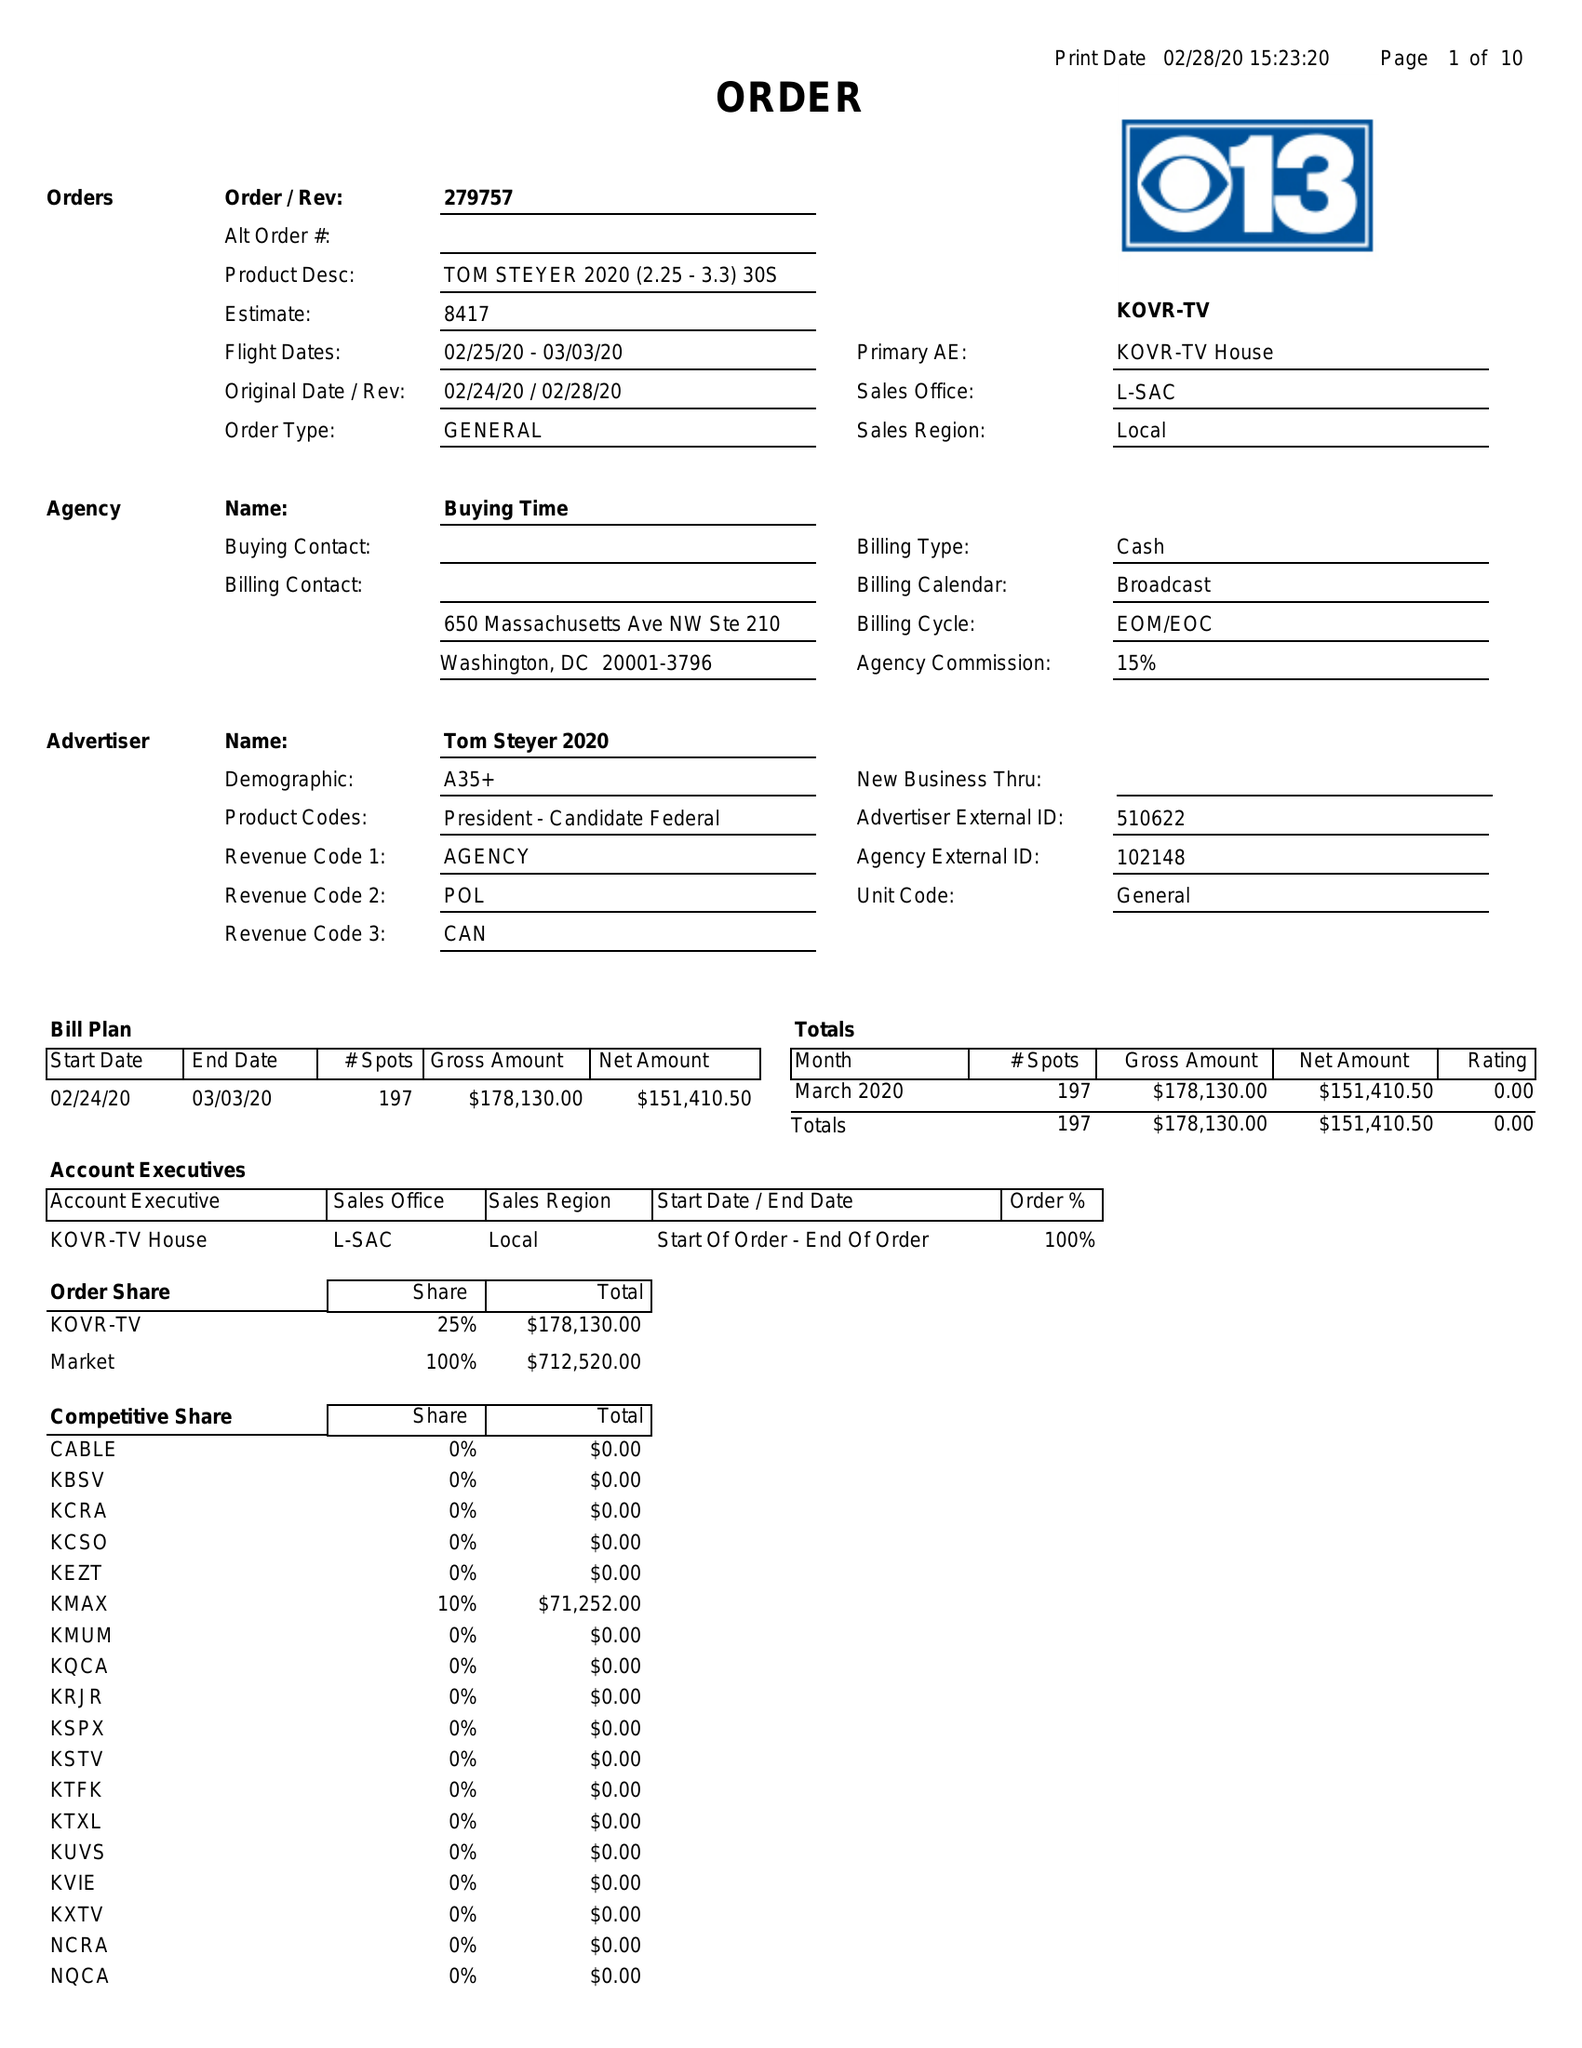What is the value for the gross_amount?
Answer the question using a single word or phrase. 178130.00 